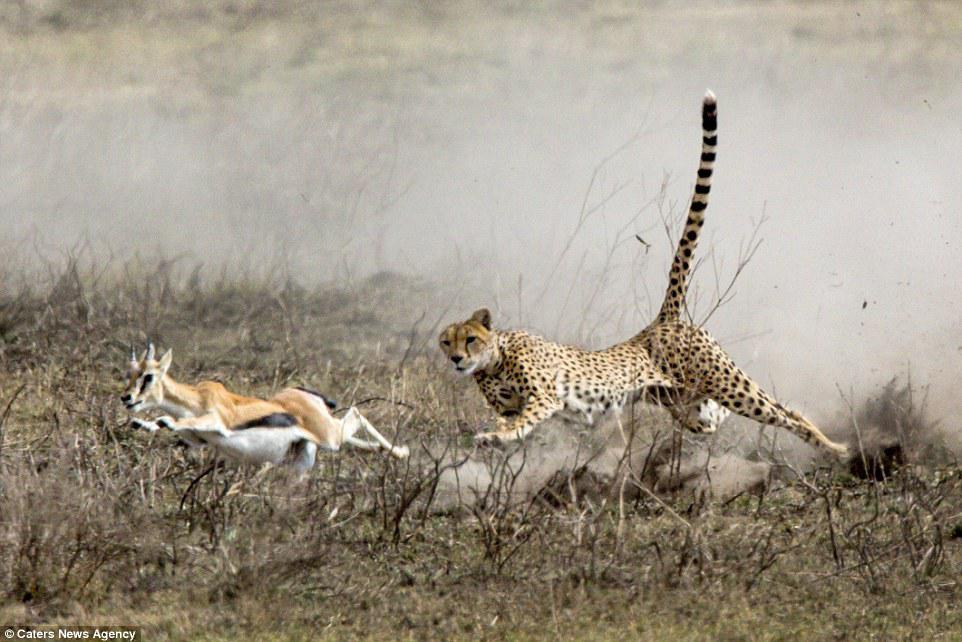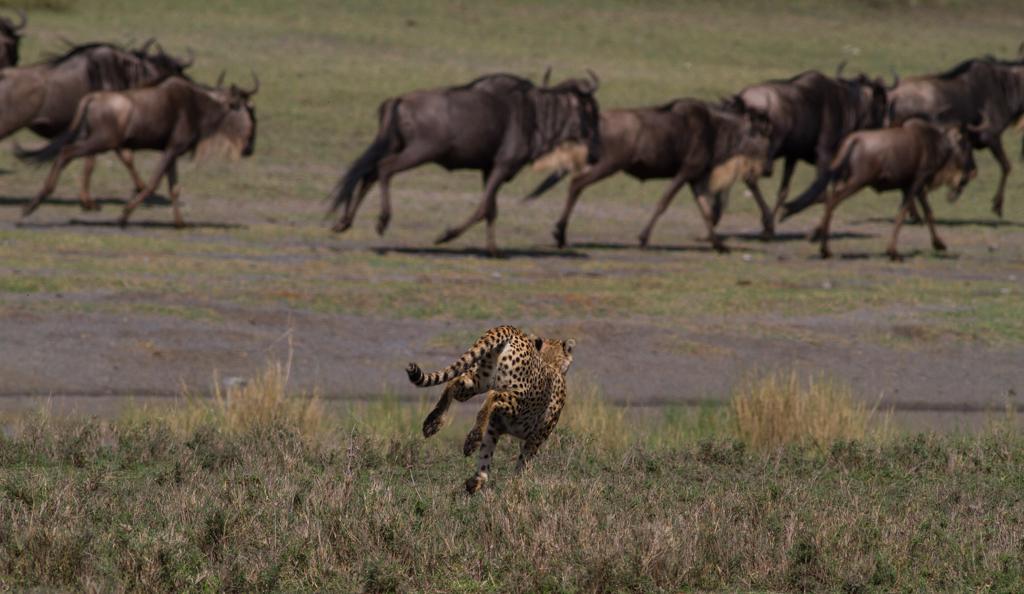The first image is the image on the left, the second image is the image on the right. Considering the images on both sides, is "At least one of the images contains a single large cat chasing a single animal with no other animals present." valid? Answer yes or no. Yes. The first image is the image on the left, the second image is the image on the right. Analyze the images presented: Is the assertion "In the left image there is one cheetah and it is running towards the left." valid? Answer yes or no. Yes. 